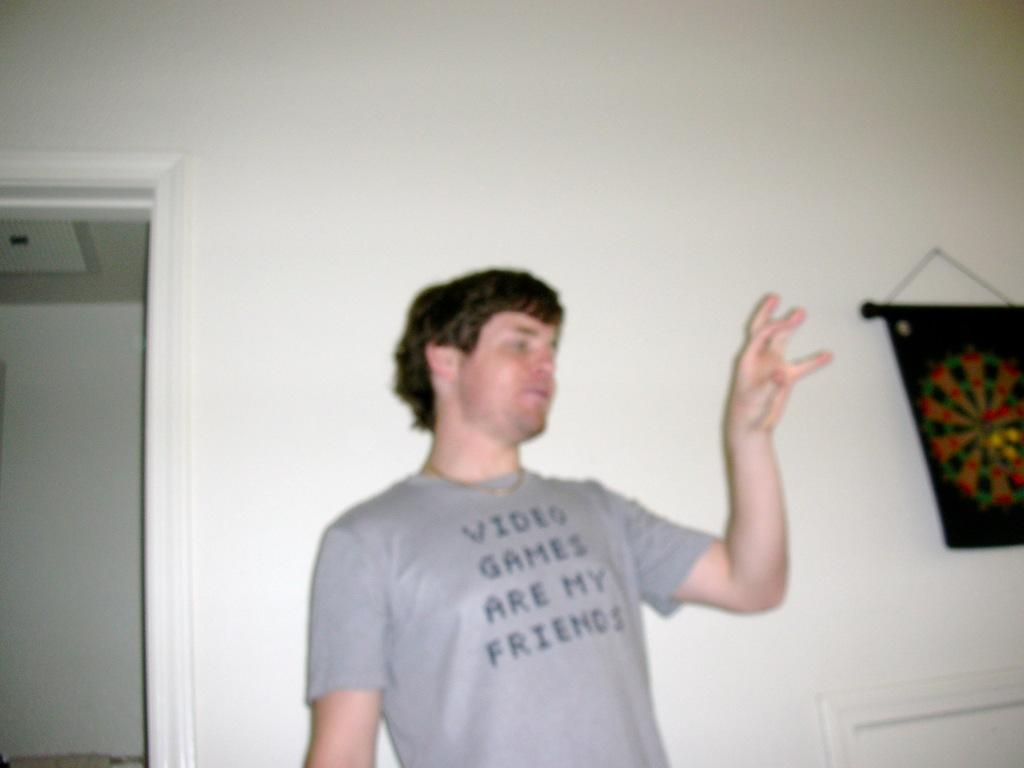What is the main subject of the image? There is a person in the image. What is the person wearing? The person is wearing a t-shirt. What is the person's posture in the image? The person is standing. What can be seen in the background of the image? There is a wall with a door in the background. What is hanging on the wall in the image? There is an object hanging on the wall. What is the governor's opinion on the taste of the t-shirt in the image? There is no governor present in the image, and the t-shirt is not an edible item, so it cannot be tasted. 